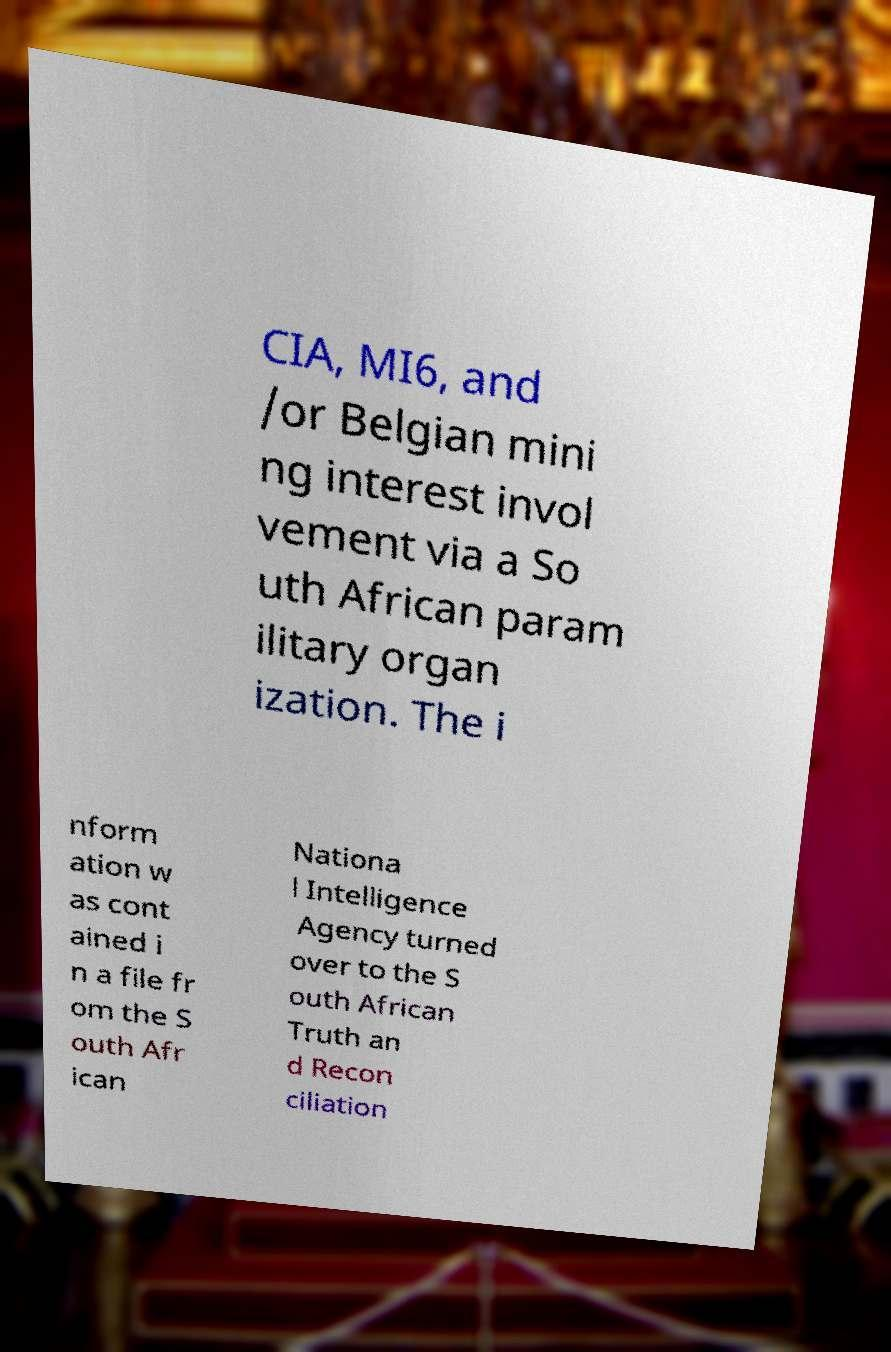Please read and relay the text visible in this image. What does it say? CIA, MI6, and /or Belgian mini ng interest invol vement via a So uth African param ilitary organ ization. The i nform ation w as cont ained i n a file fr om the S outh Afr ican Nationa l Intelligence Agency turned over to the S outh African Truth an d Recon ciliation 